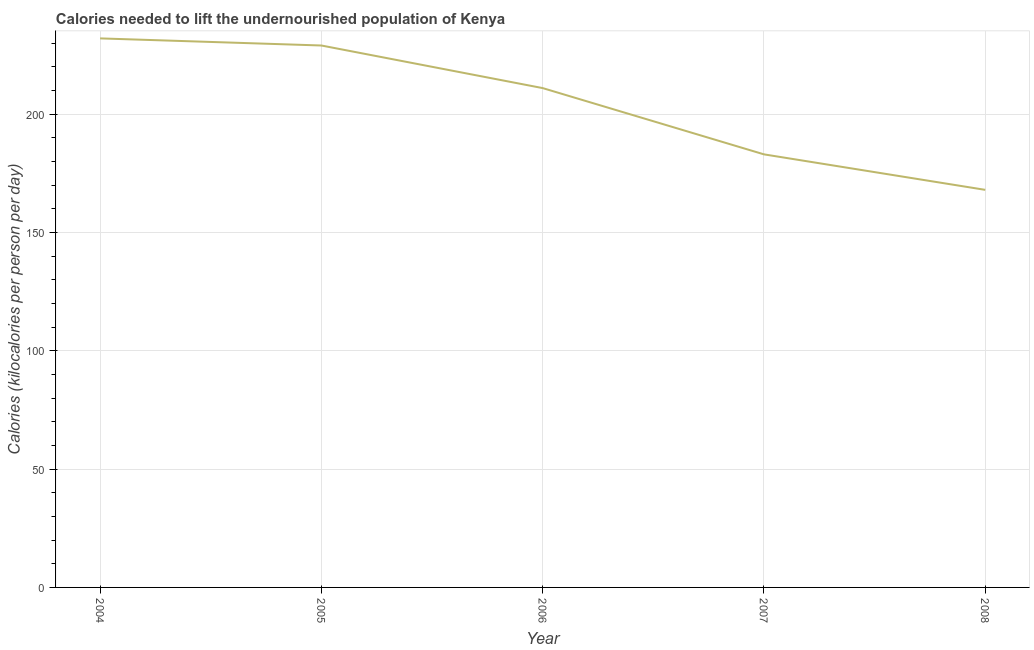What is the depth of food deficit in 2007?
Keep it short and to the point. 183. Across all years, what is the maximum depth of food deficit?
Your answer should be very brief. 232. Across all years, what is the minimum depth of food deficit?
Provide a short and direct response. 168. In which year was the depth of food deficit minimum?
Your response must be concise. 2008. What is the sum of the depth of food deficit?
Your answer should be compact. 1023. What is the difference between the depth of food deficit in 2007 and 2008?
Your response must be concise. 15. What is the average depth of food deficit per year?
Provide a succinct answer. 204.6. What is the median depth of food deficit?
Make the answer very short. 211. In how many years, is the depth of food deficit greater than 90 kilocalories?
Your answer should be very brief. 5. What is the ratio of the depth of food deficit in 2005 to that in 2007?
Offer a terse response. 1.25. Is the difference between the depth of food deficit in 2004 and 2007 greater than the difference between any two years?
Offer a terse response. No. What is the difference between the highest and the second highest depth of food deficit?
Provide a short and direct response. 3. What is the difference between the highest and the lowest depth of food deficit?
Make the answer very short. 64. In how many years, is the depth of food deficit greater than the average depth of food deficit taken over all years?
Offer a very short reply. 3. Does the depth of food deficit monotonically increase over the years?
Your answer should be very brief. No. How many years are there in the graph?
Provide a succinct answer. 5. What is the difference between two consecutive major ticks on the Y-axis?
Offer a terse response. 50. Does the graph contain any zero values?
Your answer should be compact. No. What is the title of the graph?
Your answer should be compact. Calories needed to lift the undernourished population of Kenya. What is the label or title of the Y-axis?
Keep it short and to the point. Calories (kilocalories per person per day). What is the Calories (kilocalories per person per day) of 2004?
Make the answer very short. 232. What is the Calories (kilocalories per person per day) in 2005?
Your answer should be compact. 229. What is the Calories (kilocalories per person per day) of 2006?
Keep it short and to the point. 211. What is the Calories (kilocalories per person per day) of 2007?
Your answer should be compact. 183. What is the Calories (kilocalories per person per day) of 2008?
Your response must be concise. 168. What is the difference between the Calories (kilocalories per person per day) in 2004 and 2006?
Give a very brief answer. 21. What is the difference between the Calories (kilocalories per person per day) in 2004 and 2007?
Provide a short and direct response. 49. What is the difference between the Calories (kilocalories per person per day) in 2004 and 2008?
Keep it short and to the point. 64. What is the difference between the Calories (kilocalories per person per day) in 2005 and 2006?
Make the answer very short. 18. What is the difference between the Calories (kilocalories per person per day) in 2005 and 2007?
Make the answer very short. 46. What is the difference between the Calories (kilocalories per person per day) in 2005 and 2008?
Ensure brevity in your answer.  61. What is the difference between the Calories (kilocalories per person per day) in 2006 and 2007?
Your answer should be compact. 28. What is the difference between the Calories (kilocalories per person per day) in 2006 and 2008?
Ensure brevity in your answer.  43. What is the difference between the Calories (kilocalories per person per day) in 2007 and 2008?
Give a very brief answer. 15. What is the ratio of the Calories (kilocalories per person per day) in 2004 to that in 2005?
Offer a terse response. 1.01. What is the ratio of the Calories (kilocalories per person per day) in 2004 to that in 2006?
Give a very brief answer. 1.1. What is the ratio of the Calories (kilocalories per person per day) in 2004 to that in 2007?
Make the answer very short. 1.27. What is the ratio of the Calories (kilocalories per person per day) in 2004 to that in 2008?
Your response must be concise. 1.38. What is the ratio of the Calories (kilocalories per person per day) in 2005 to that in 2006?
Your answer should be very brief. 1.08. What is the ratio of the Calories (kilocalories per person per day) in 2005 to that in 2007?
Offer a very short reply. 1.25. What is the ratio of the Calories (kilocalories per person per day) in 2005 to that in 2008?
Provide a short and direct response. 1.36. What is the ratio of the Calories (kilocalories per person per day) in 2006 to that in 2007?
Give a very brief answer. 1.15. What is the ratio of the Calories (kilocalories per person per day) in 2006 to that in 2008?
Keep it short and to the point. 1.26. What is the ratio of the Calories (kilocalories per person per day) in 2007 to that in 2008?
Offer a terse response. 1.09. 